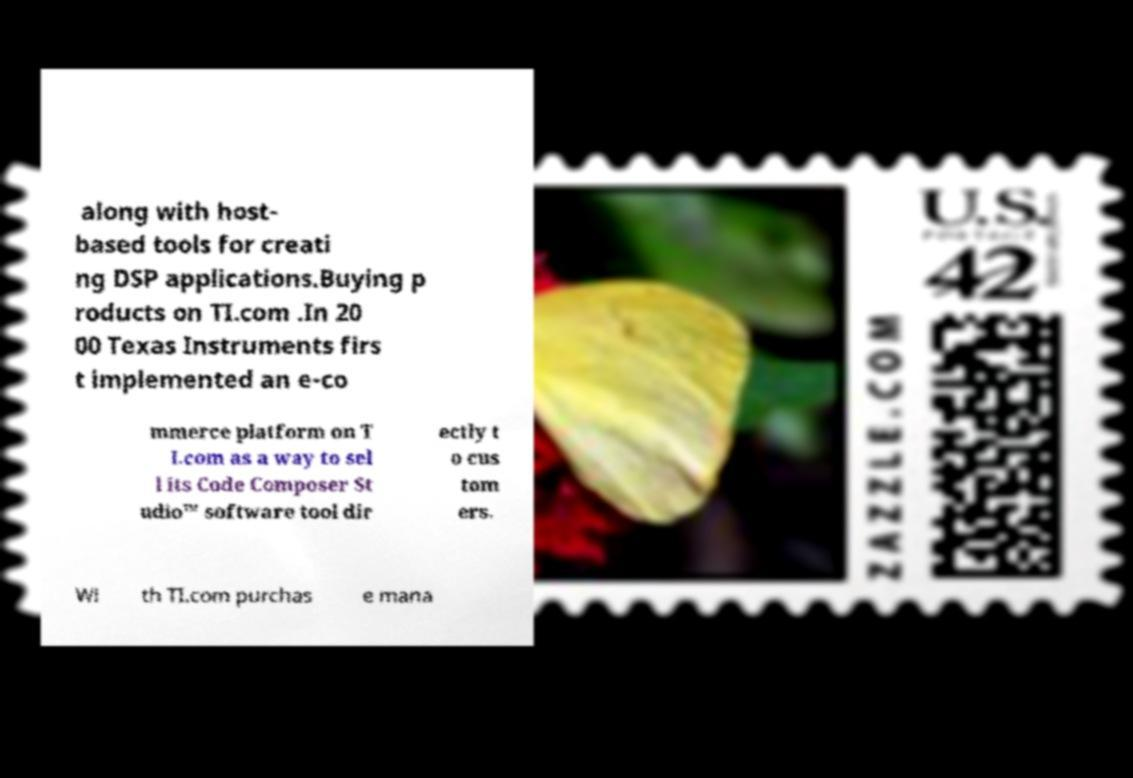There's text embedded in this image that I need extracted. Can you transcribe it verbatim? along with host- based tools for creati ng DSP applications.Buying p roducts on TI.com .In 20 00 Texas Instruments firs t implemented an e-co mmerce platform on T I.com as a way to sel l its Code Composer St udio™ software tool dir ectly t o cus tom ers. Wi th TI.com purchas e mana 